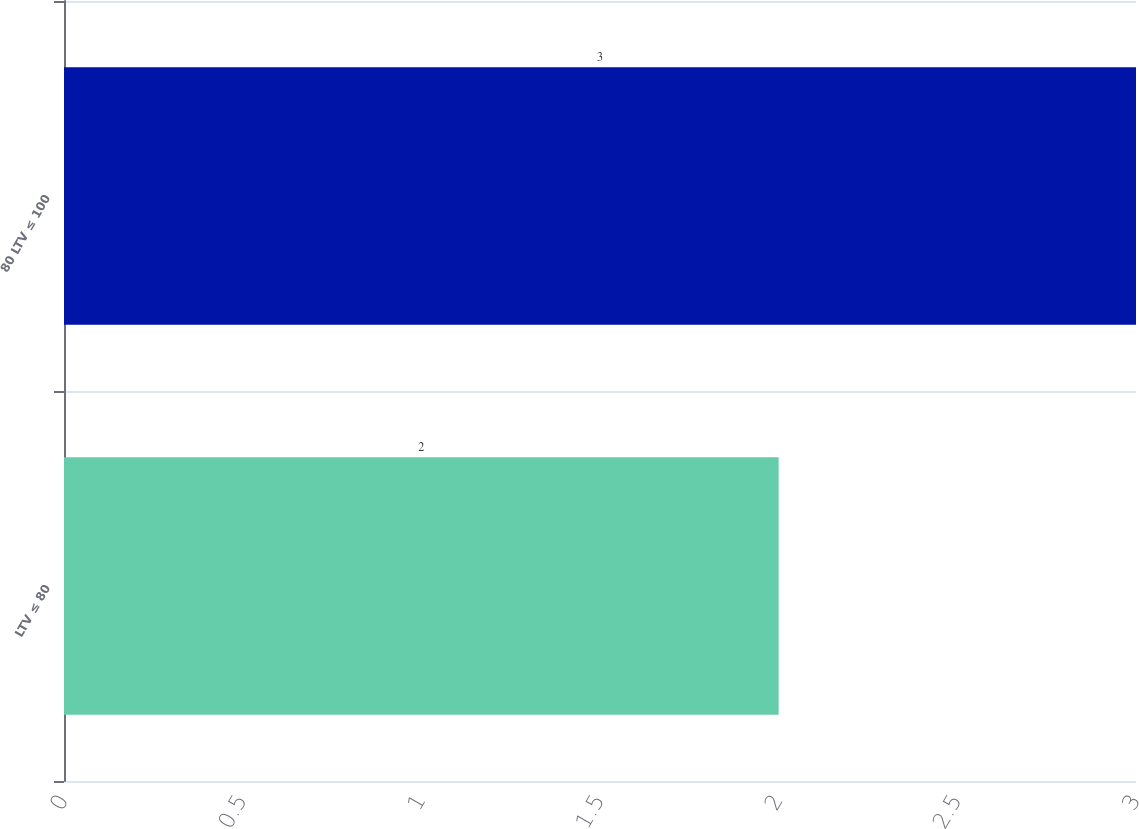Convert chart. <chart><loc_0><loc_0><loc_500><loc_500><bar_chart><fcel>LTV ≤ 80<fcel>80 LTV ≤ 100<nl><fcel>2<fcel>3<nl></chart> 